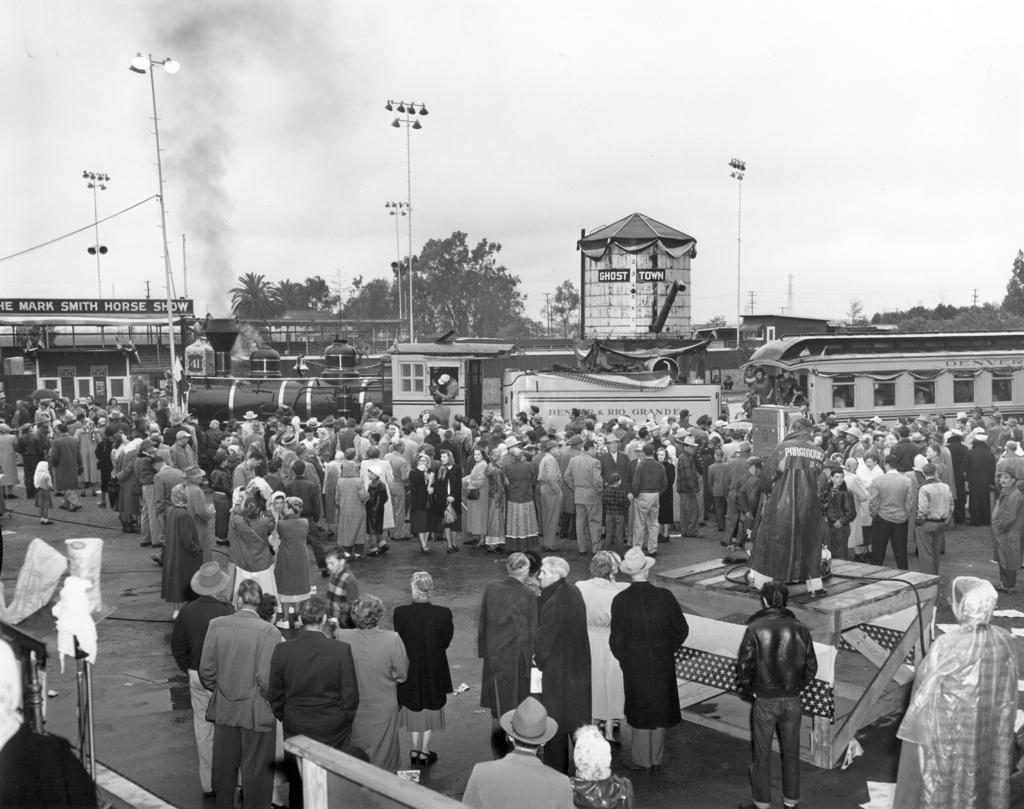How would you summarize this image in a sentence or two? This is a black and white image. In the center of the image there are people standing on the road. There is a train. In the background of the image there are trees. There are street lights. 